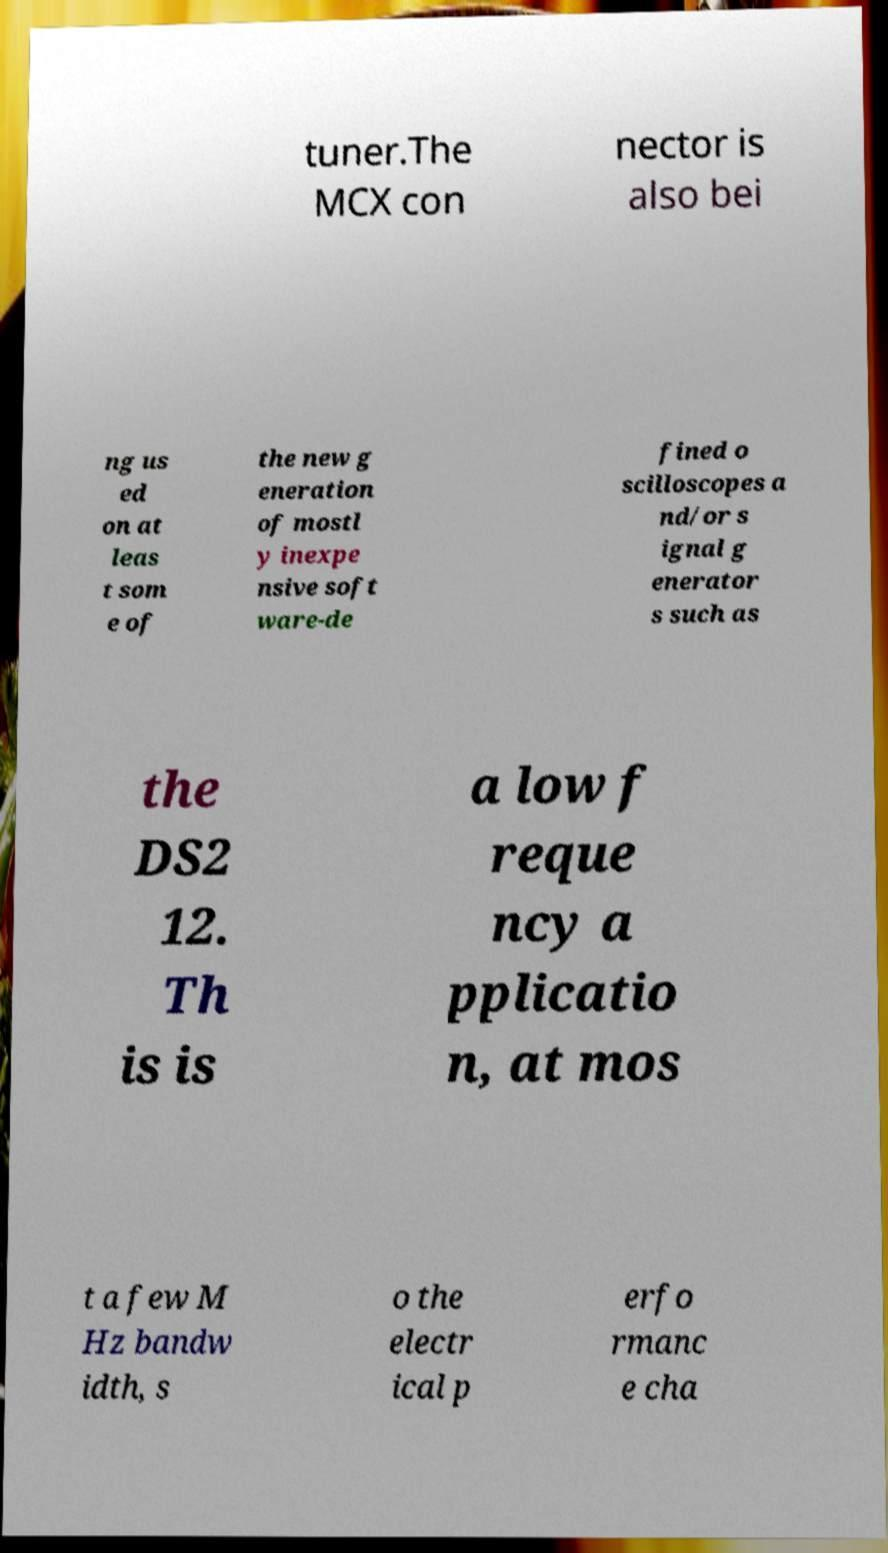Can you read and provide the text displayed in the image?This photo seems to have some interesting text. Can you extract and type it out for me? tuner.The MCX con nector is also bei ng us ed on at leas t som e of the new g eneration of mostl y inexpe nsive soft ware-de fined o scilloscopes a nd/or s ignal g enerator s such as the DS2 12. Th is is a low f reque ncy a pplicatio n, at mos t a few M Hz bandw idth, s o the electr ical p erfo rmanc e cha 